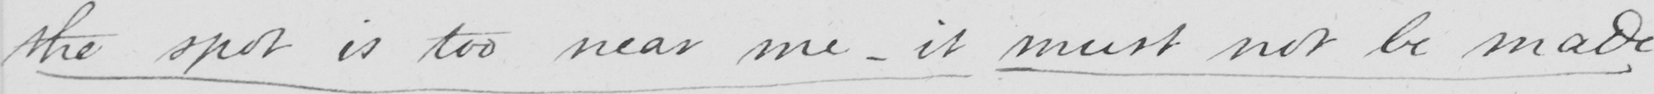Please provide the text content of this handwritten line. the spot is too near me  _  it must not be made 